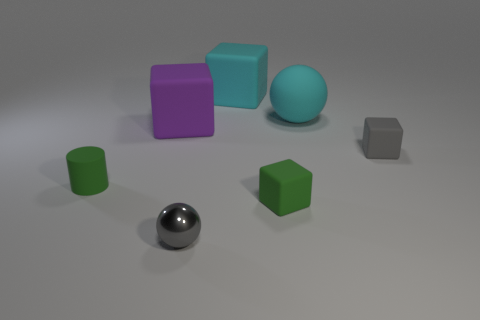Is the number of tiny gray metal things behind the small metallic ball less than the number of big things right of the green block?
Make the answer very short. Yes. The gray block is what size?
Your answer should be very brief. Small. What number of small objects are either green matte blocks or cylinders?
Keep it short and to the point. 2. Does the cylinder have the same size as the rubber block behind the large purple matte thing?
Your answer should be compact. No. What number of purple cylinders are there?
Offer a terse response. 0. What number of gray objects are small matte objects or large spheres?
Your answer should be very brief. 1. Is the big block to the left of the gray sphere made of the same material as the tiny green cylinder?
Offer a very short reply. Yes. What number of other objects are there of the same material as the purple object?
Your answer should be very brief. 5. What is the tiny gray cube made of?
Provide a short and direct response. Rubber. What size is the gray matte cube in front of the purple block?
Your response must be concise. Small. 